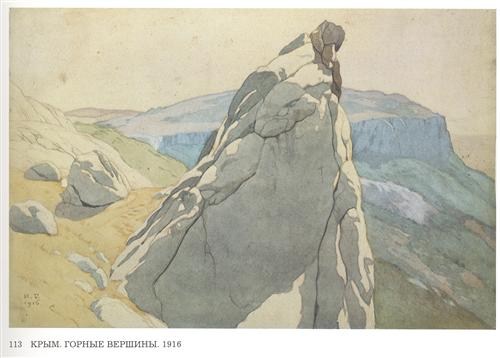Describe a possible story or event taking place in this scene. In this tranquil landscape, one might imagine a lone hiker having reached the summit of the rocky cliff in the early morning. As the sun rises, the hiker could be taking a moment of reflection, overlooking the vast expanse of the Crimean Mountains stretching into the distance. This serene moment stands as a testament to the journey and effort required to reach such heights, symbolizing personal achievement and the profound connection between humans and nature. Can you suggest a title for this painting? A fitting title for this painting might be 'Serenity on the Summit' or 'Morning Calm in the Crimean Mountains,' both capturing the peaceful essence and natural beauty of the scene. How might the inclusion of wildlife change the dynamics of this painting? Incorporating wildlife into the painting would infuse it with additional layers of life and activity. Imagine a single eagle soaring above the cliffs or a herd of deer grazing in the distant valleys; such elements would add movement and interest, as well as a deeper connection to the natural setting. Wildlife would introduce a sense of scale to the landscape, emphasizing the vastness of the mountains and the interdependence of all living things with their environment. 